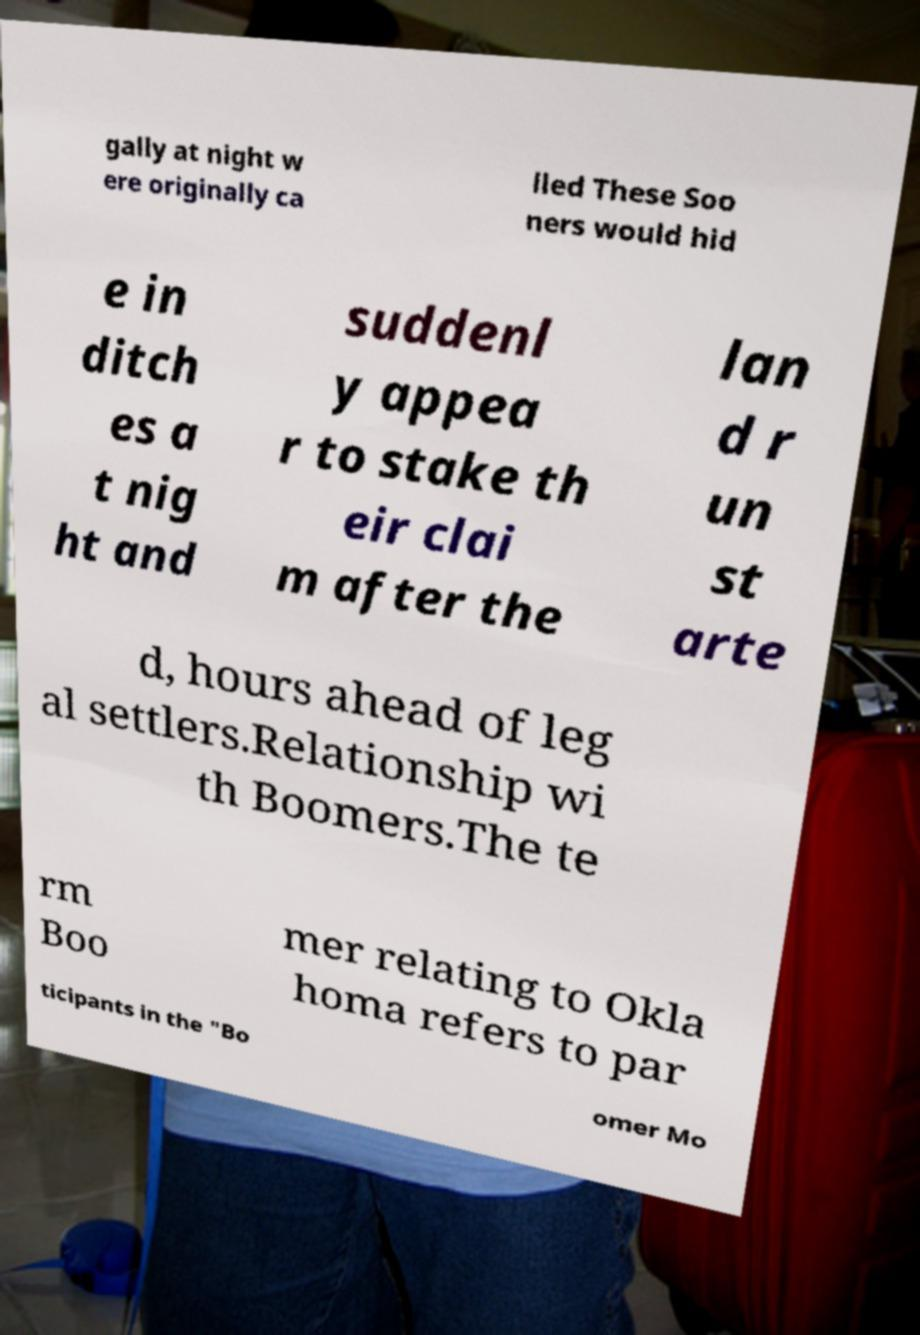I need the written content from this picture converted into text. Can you do that? gally at night w ere originally ca lled These Soo ners would hid e in ditch es a t nig ht and suddenl y appea r to stake th eir clai m after the lan d r un st arte d, hours ahead of leg al settlers.Relationship wi th Boomers.The te rm Boo mer relating to Okla homa refers to par ticipants in the "Bo omer Mo 